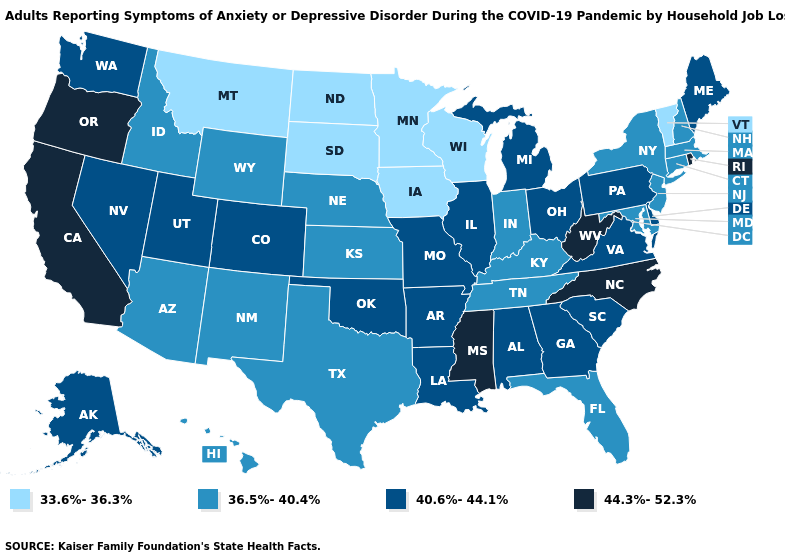Among the states that border Georgia , does Tennessee have the lowest value?
Write a very short answer. Yes. Which states have the highest value in the USA?
Short answer required. California, Mississippi, North Carolina, Oregon, Rhode Island, West Virginia. Name the states that have a value in the range 33.6%-36.3%?
Concise answer only. Iowa, Minnesota, Montana, North Dakota, South Dakota, Vermont, Wisconsin. What is the lowest value in the USA?
Answer briefly. 33.6%-36.3%. Does South Carolina have a lower value than Oregon?
Give a very brief answer. Yes. Does Alaska have a higher value than Oklahoma?
Give a very brief answer. No. Name the states that have a value in the range 44.3%-52.3%?
Short answer required. California, Mississippi, North Carolina, Oregon, Rhode Island, West Virginia. How many symbols are there in the legend?
Be succinct. 4. Among the states that border Arizona , does California have the lowest value?
Be succinct. No. Does Maine have the same value as Wisconsin?
Be succinct. No. Name the states that have a value in the range 44.3%-52.3%?
Keep it brief. California, Mississippi, North Carolina, Oregon, Rhode Island, West Virginia. What is the value of Indiana?
Give a very brief answer. 36.5%-40.4%. What is the value of Alabama?
Be succinct. 40.6%-44.1%. Name the states that have a value in the range 33.6%-36.3%?
Answer briefly. Iowa, Minnesota, Montana, North Dakota, South Dakota, Vermont, Wisconsin. Does Florida have the highest value in the USA?
Quick response, please. No. 